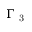<formula> <loc_0><loc_0><loc_500><loc_500>\Gamma _ { 3 }</formula> 